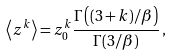<formula> <loc_0><loc_0><loc_500><loc_500>\left \langle z ^ { k } \right \rangle = z _ { 0 } ^ { k } \frac { \Gamma \left ( ( 3 + k ) / \beta \right ) } { \Gamma ( 3 / \beta ) } \, ,</formula> 